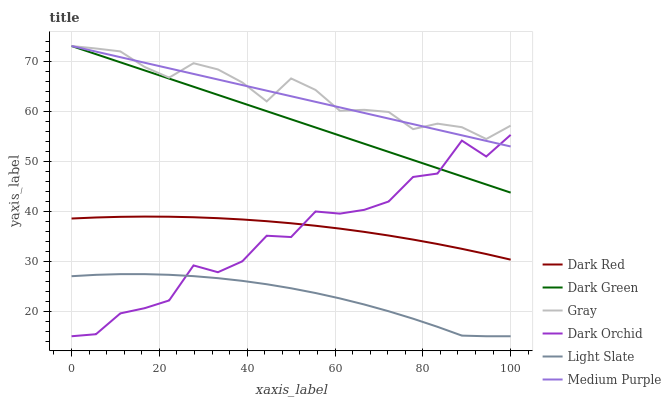Does Light Slate have the minimum area under the curve?
Answer yes or no. Yes. Does Gray have the maximum area under the curve?
Answer yes or no. Yes. Does Dark Red have the minimum area under the curve?
Answer yes or no. No. Does Dark Red have the maximum area under the curve?
Answer yes or no. No. Is Dark Green the smoothest?
Answer yes or no. Yes. Is Dark Orchid the roughest?
Answer yes or no. Yes. Is Light Slate the smoothest?
Answer yes or no. No. Is Light Slate the roughest?
Answer yes or no. No. Does Dark Red have the lowest value?
Answer yes or no. No. Does Dark Green have the highest value?
Answer yes or no. Yes. Does Dark Red have the highest value?
Answer yes or no. No. Is Dark Red less than Dark Green?
Answer yes or no. Yes. Is Gray greater than Light Slate?
Answer yes or no. Yes. Does Medium Purple intersect Dark Green?
Answer yes or no. Yes. Is Medium Purple less than Dark Green?
Answer yes or no. No. Is Medium Purple greater than Dark Green?
Answer yes or no. No. Does Dark Red intersect Dark Green?
Answer yes or no. No. 